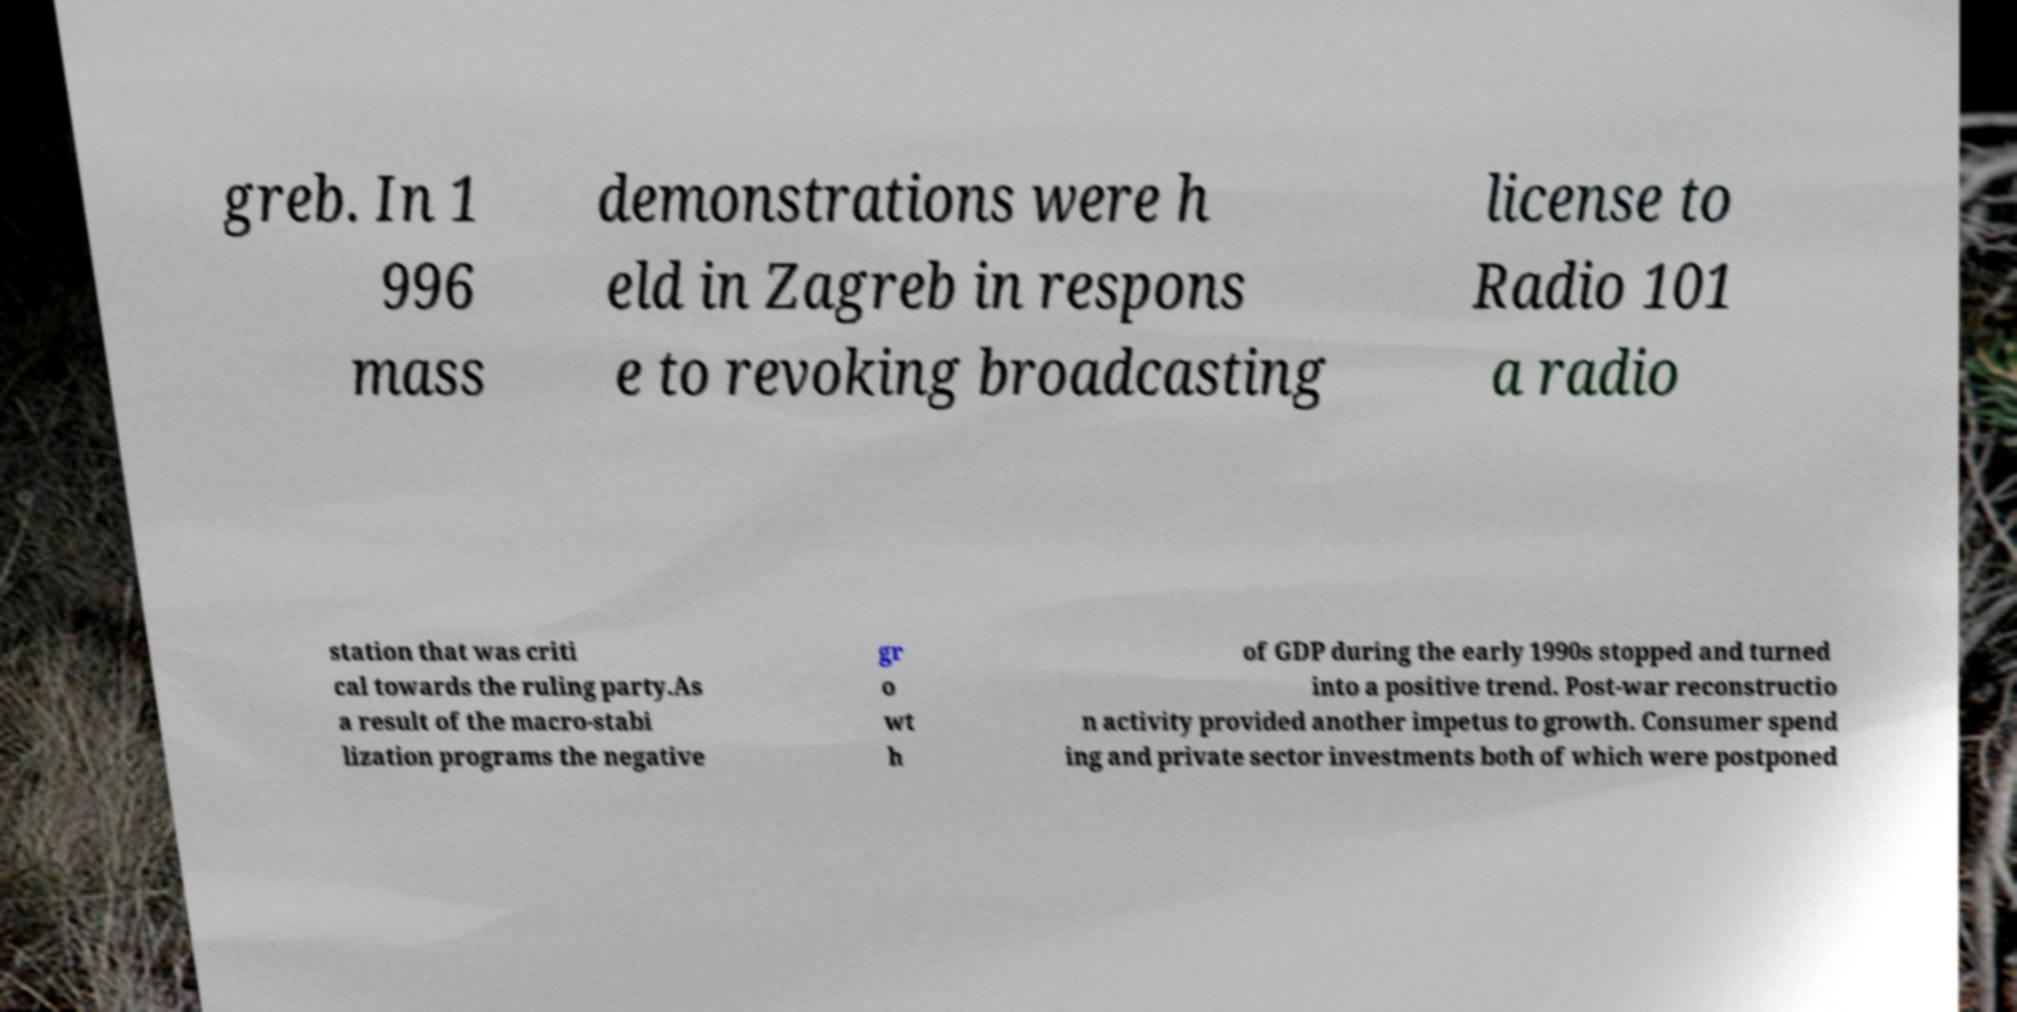Please read and relay the text visible in this image. What does it say? greb. In 1 996 mass demonstrations were h eld in Zagreb in respons e to revoking broadcasting license to Radio 101 a radio station that was criti cal towards the ruling party.As a result of the macro-stabi lization programs the negative gr o wt h of GDP during the early 1990s stopped and turned into a positive trend. Post-war reconstructio n activity provided another impetus to growth. Consumer spend ing and private sector investments both of which were postponed 